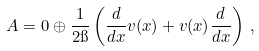Convert formula to latex. <formula><loc_0><loc_0><loc_500><loc_500>A = 0 \oplus \frac { 1 } { 2 \i } \left ( \frac { d } { d x } v ( x ) + v ( x ) \frac { d } { d x } \right ) \, ,</formula> 